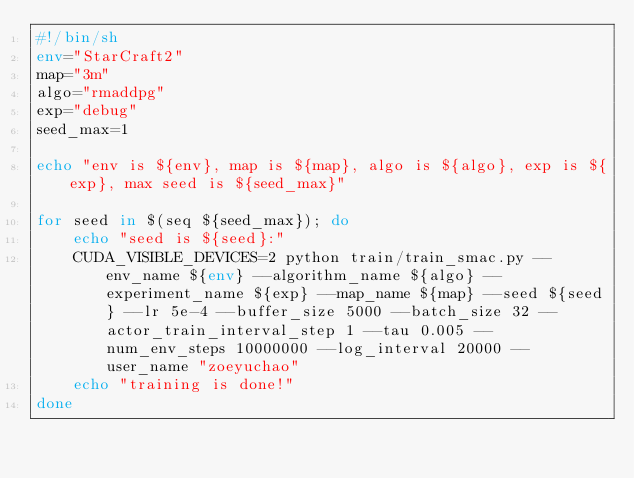Convert code to text. <code><loc_0><loc_0><loc_500><loc_500><_Bash_>#!/bin/sh
env="StarCraft2"
map="3m"
algo="rmaddpg"
exp="debug"
seed_max=1

echo "env is ${env}, map is ${map}, algo is ${algo}, exp is ${exp}, max seed is ${seed_max}"

for seed in $(seq ${seed_max}); do
    echo "seed is ${seed}:"
    CUDA_VISIBLE_DEVICES=2 python train/train_smac.py --env_name ${env} --algorithm_name ${algo} --experiment_name ${exp} --map_name ${map} --seed ${seed} --lr 5e-4 --buffer_size 5000 --batch_size 32 --actor_train_interval_step 1 --tau 0.005 --num_env_steps 10000000 --log_interval 20000 --user_name "zoeyuchao"
    echo "training is done!"
done
</code> 